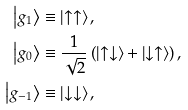Convert formula to latex. <formula><loc_0><loc_0><loc_500><loc_500>\left | g _ { 1 } \right \rangle & \equiv \left | \uparrow \uparrow \right \rangle , \\ \left | g _ { 0 } \right \rangle & \equiv \frac { 1 } { \sqrt { 2 } } \left ( \left | \uparrow \downarrow \right \rangle + \left | \downarrow \uparrow \right \rangle \right ) , \\ \left | g _ { - 1 } \right \rangle & \equiv \left | \downarrow \downarrow \right \rangle ,</formula> 